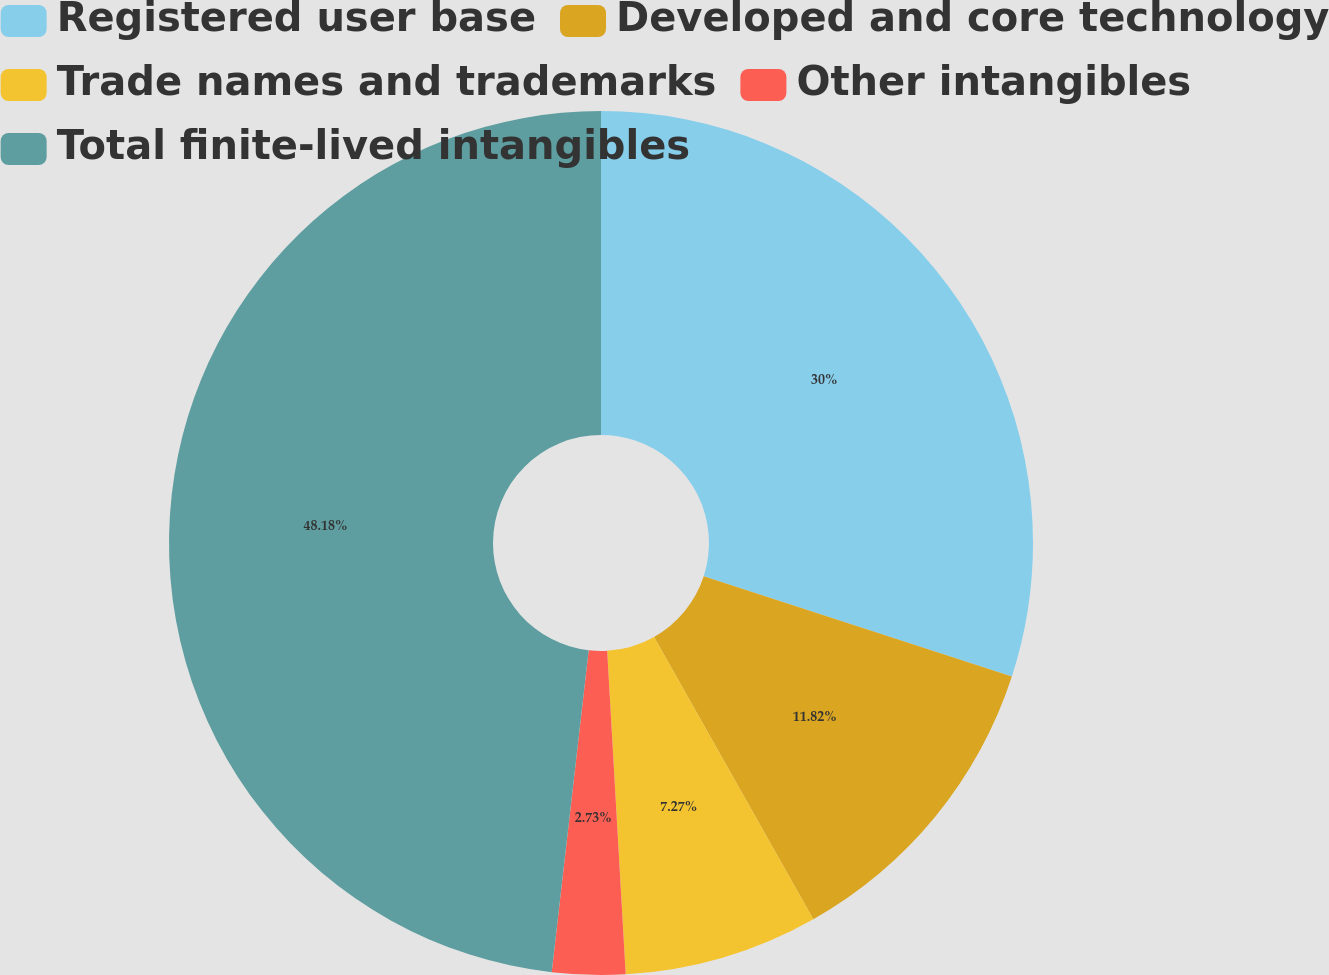<chart> <loc_0><loc_0><loc_500><loc_500><pie_chart><fcel>Registered user base<fcel>Developed and core technology<fcel>Trade names and trademarks<fcel>Other intangibles<fcel>Total finite-lived intangibles<nl><fcel>30.0%<fcel>11.82%<fcel>7.27%<fcel>2.73%<fcel>48.18%<nl></chart> 